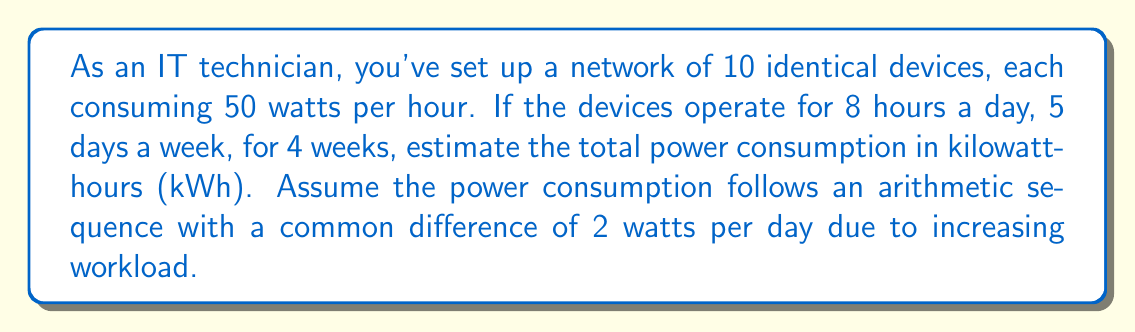Show me your answer to this math problem. Let's break this down step-by-step:

1) First, calculate the initial daily power consumption:
   $$ 10 \text{ devices} \times 50 \text{ watts} \times 8 \text{ hours} = 4000 \text{ watt-hours} = 4 \text{ kWh} $$

2) The sequence of daily consumption forms an arithmetic sequence with:
   - Initial term $a_1 = 4$ kWh
   - Common difference $d = 10 \text{ devices} \times 2 \text{ watts} \times 8 \text{ hours} = 160 \text{ watt-hours} = 0.16 \text{ kWh}$

3) Number of terms: 5 days/week × 4 weeks = 20 days

4) Use the arithmetic sequence sum formula:
   $$ S_n = \frac{n}{2}(a_1 + a_n) $$
   where $a_n = a_1 + (n-1)d = 4 + (20-1)(0.16) = 7.04$

5) Plugging in the values:
   $$ S_{20} = \frac{20}{2}(4 + 7.04) = 10(11.04) = 110.4 \text{ kWh} $$

Therefore, the total power consumption over the 4-week period is approximately 110.4 kWh.
Answer: 110.4 kWh 